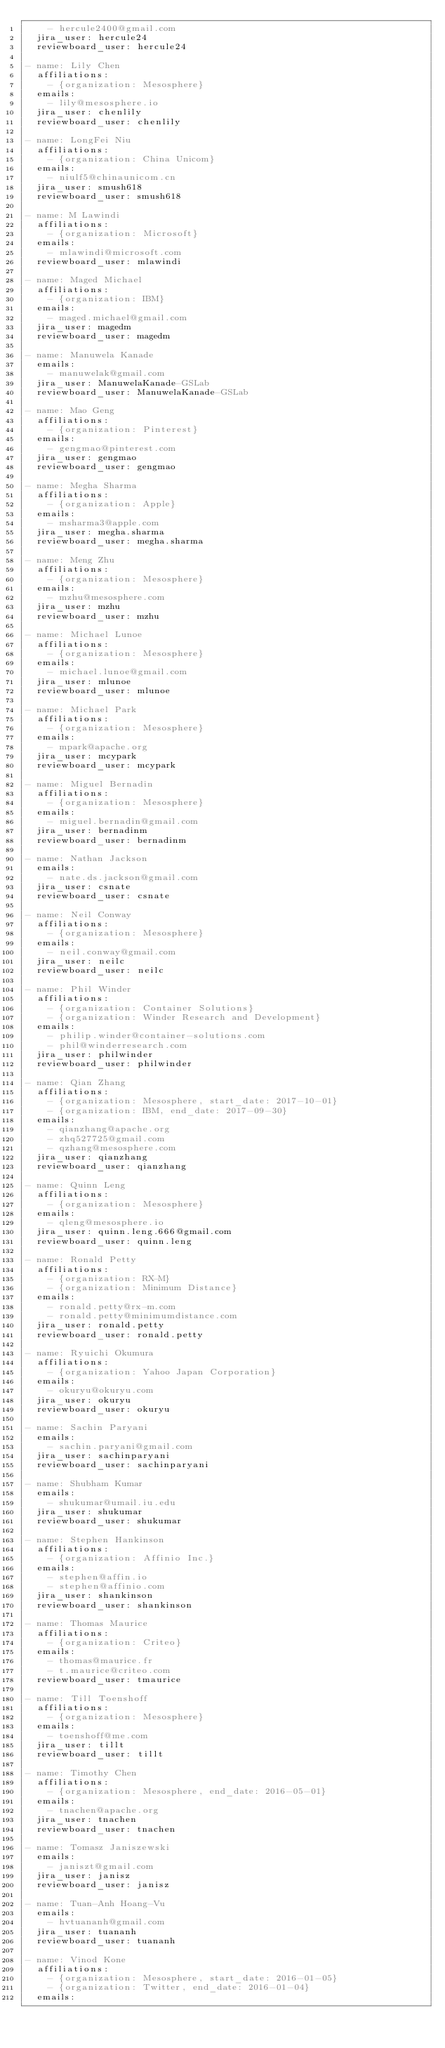Convert code to text. <code><loc_0><loc_0><loc_500><loc_500><_YAML_>    - hercule2400@gmail.com
  jira_user: hercule24
  reviewboard_user: hercule24

- name: Lily Chen
  affiliations:
    - {organization: Mesosphere}
  emails:
    - lily@mesosphere.io
  jira_user: chenlily
  reviewboard_user: chenlily

- name: LongFei Niu
  affiliations:
    - {organization: China Unicom}
  emails:
    - niulf5@chinaunicom.cn
  jira_user: smush618
  reviewboard_user: smush618

- name: M Lawindi
  affiliations:
    - {organization: Microsoft}
  emails:
    - mlawindi@microsoft.com
  reviewboard_user: mlawindi

- name: Maged Michael
  affiliations:
    - {organization: IBM}
  emails:
    - maged.michael@gmail.com
  jira_user: magedm
  reviewboard_user: magedm

- name: Manuwela Kanade
  emails:
    - manuwelak@gmail.com
  jira_user: ManuwelaKanade-GSLab
  reviewboard_user: ManuwelaKanade-GSLab

- name: Mao Geng
  affiliations:
    - {organization: Pinterest}
  emails:
    - gengmao@pinterest.com
  jira_user: gengmao
  reviewboard_user: gengmao

- name: Megha Sharma
  affiliations:
    - {organization: Apple}
  emails:
    - msharma3@apple.com
  jira_user: megha.sharma
  reviewboard_user: megha.sharma

- name: Meng Zhu
  affiliations:
    - {organization: Mesosphere}
  emails:
    - mzhu@mesosphere.com
  jira_user: mzhu
  reviewboard_user: mzhu

- name: Michael Lunoe
  affiliations:
    - {organization: Mesosphere}
  emails:
    - michael.lunoe@gmail.com
  jira_user: mlunoe
  reviewboard_user: mlunoe

- name: Michael Park
  affiliations:
    - {organization: Mesosphere}
  emails:
    - mpark@apache.org
  jira_user: mcypark
  reviewboard_user: mcypark

- name: Miguel Bernadin
  affiliations:
    - {organization: Mesosphere}
  emails:
    - miguel.bernadin@gmail.com
  jira_user: bernadinm
  reviewboard_user: bernadinm

- name: Nathan Jackson
  emails:
    - nate.ds.jackson@gmail.com
  jira_user: csnate
  reviewboard_user: csnate

- name: Neil Conway
  affiliations:
    - {organization: Mesosphere}
  emails:
    - neil.conway@gmail.com
  jira_user: neilc
  reviewboard_user: neilc

- name: Phil Winder
  affiliations:
    - {organization: Container Solutions}
    - {organization: Winder Research and Development}
  emails:
    - philip.winder@container-solutions.com
    - phil@winderresearch.com
  jira_user: philwinder
  reviewboard_user: philwinder

- name: Qian Zhang
  affiliations:
    - {organization: Mesosphere, start_date: 2017-10-01}
    - {organization: IBM, end_date: 2017-09-30}
  emails:
    - qianzhang@apache.org
    - zhq527725@gmail.com
    - qzhang@mesosphere.com
  jira_user: qianzhang
  reviewboard_user: qianzhang

- name: Quinn Leng
  affiliations:
    - {organization: Mesosphere}
  emails:
    - qleng@mesosphere.io
  jira_user: quinn.leng.666@gmail.com
  reviewboard_user: quinn.leng

- name: Ronald Petty
  affiliations:
    - {organization: RX-M}
    - {organization: Minimum Distance}
  emails:
    - ronald.petty@rx-m.com
    - ronald.petty@minimumdistance.com
  jira_user: ronald.petty
  reviewboard_user: ronald.petty

- name: Ryuichi Okumura
  affiliations:
    - {organization: Yahoo Japan Corporation}
  emails:
    - okuryu@okuryu.com
  jira_user: okuryu
  reviewboard_user: okuryu

- name: Sachin Paryani
  emails:
    - sachin.paryani@gmail.com
  jira_user: sachinparyani
  reviewboard_user: sachinparyani

- name: Shubham Kumar
  emails:
    - shukumar@umail.iu.edu
  jira_user: shukumar
  reviewboard_user: shukumar

- name: Stephen Hankinson
  affiliations:
    - {organization: Affinio Inc.}
  emails:
    - stephen@affin.io
    - stephen@affinio.com
  jira_user: shankinson
  reviewboard_user: shankinson

- name: Thomas Maurice
  affiliations:
    - {organization: Criteo}
  emails:
    - thomas@maurice.fr
    - t.maurice@criteo.com
  reviewboard_user: tmaurice

- name: Till Toenshoff
  affiliations:
    - {organization: Mesosphere}
  emails:
    - toenshoff@me.com
  jira_user: tillt
  reviewboard_user: tillt

- name: Timothy Chen
  affiliations:
    - {organization: Mesosphere, end_date: 2016-05-01}
  emails:
    - tnachen@apache.org
  jira_user: tnachen
  reviewboard_user: tnachen

- name: Tomasz Janiszewski
  emails:
    - janiszt@gmail.com
  jira_user: janisz
  reviewboard_user: janisz

- name: Tuan-Anh Hoang-Vu
  emails:
    - hvtuananh@gmail.com
  jira_user: tuananh
  reviewboard_user: tuananh

- name: Vinod Kone
  affiliations:
    - {organization: Mesosphere, start_date: 2016-01-05}
    - {organization: Twitter, end_date: 2016-01-04}
  emails:</code> 